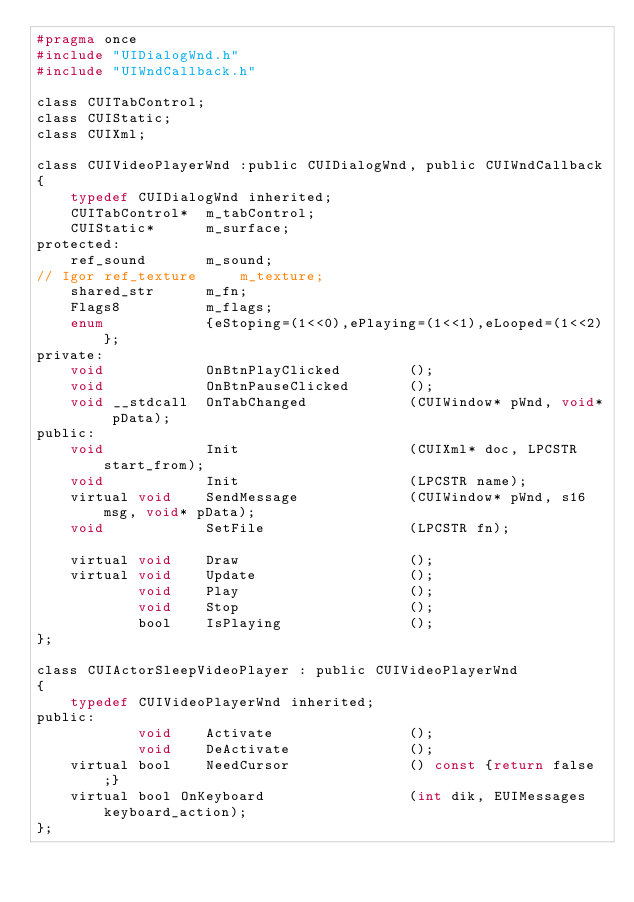Convert code to text. <code><loc_0><loc_0><loc_500><loc_500><_C_>#pragma once
#include "UIDialogWnd.h"
#include "UIWndCallback.h"

class CUITabControl;
class CUIStatic;
class CUIXml;

class CUIVideoPlayerWnd :public CUIDialogWnd, public CUIWndCallback
{
	typedef CUIDialogWnd inherited;
	CUITabControl*	m_tabControl;
	CUIStatic*		m_surface;
protected:
	ref_sound		m_sound;
// Igor	ref_texture		m_texture;
	shared_str		m_fn;
	Flags8			m_flags;
	enum			{eStoping=(1<<0),ePlaying=(1<<1),eLooped=(1<<2)};
private:
	void			OnBtnPlayClicked		();
	void			OnBtnPauseClicked		();
	void __stdcall	OnTabChanged			(CUIWindow* pWnd, void* pData);
public:
	void			Init					(CUIXml* doc, LPCSTR start_from);
	void			Init					(LPCSTR name);
	virtual void	SendMessage				(CUIWindow* pWnd, s16 msg, void* pData);
	void			SetFile					(LPCSTR fn);

	virtual void	Draw					();
	virtual void	Update					();
			void	Play					();
			void	Stop					();
			bool	IsPlaying				();
};

class CUIActorSleepVideoPlayer : public CUIVideoPlayerWnd
{
	typedef CUIVideoPlayerWnd inherited;
public:
			void	Activate				();
			void	DeActivate				();
	virtual bool	NeedCursor				() const {return false;}
	virtual bool OnKeyboard					(int dik, EUIMessages keyboard_action);
};</code> 